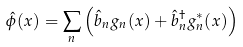<formula> <loc_0><loc_0><loc_500><loc_500>\hat { \phi } ( x ) = \sum _ { n } \left ( \hat { b } _ { n } g _ { n } ( x ) + \hat { b } ^ { \dagger } _ { n } g _ { n } ^ { * } ( x ) \right )</formula> 